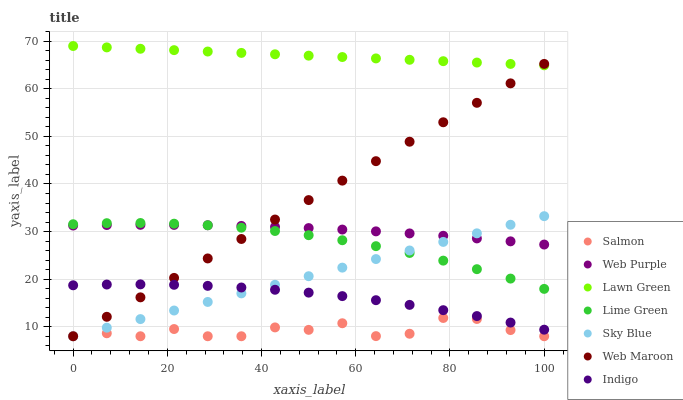Does Salmon have the minimum area under the curve?
Answer yes or no. Yes. Does Lawn Green have the maximum area under the curve?
Answer yes or no. Yes. Does Indigo have the minimum area under the curve?
Answer yes or no. No. Does Indigo have the maximum area under the curve?
Answer yes or no. No. Is Sky Blue the smoothest?
Answer yes or no. Yes. Is Salmon the roughest?
Answer yes or no. Yes. Is Indigo the smoothest?
Answer yes or no. No. Is Indigo the roughest?
Answer yes or no. No. Does Salmon have the lowest value?
Answer yes or no. Yes. Does Indigo have the lowest value?
Answer yes or no. No. Does Lawn Green have the highest value?
Answer yes or no. Yes. Does Indigo have the highest value?
Answer yes or no. No. Is Salmon less than Indigo?
Answer yes or no. Yes. Is Lawn Green greater than Lime Green?
Answer yes or no. Yes. Does Web Maroon intersect Salmon?
Answer yes or no. Yes. Is Web Maroon less than Salmon?
Answer yes or no. No. Is Web Maroon greater than Salmon?
Answer yes or no. No. Does Salmon intersect Indigo?
Answer yes or no. No. 